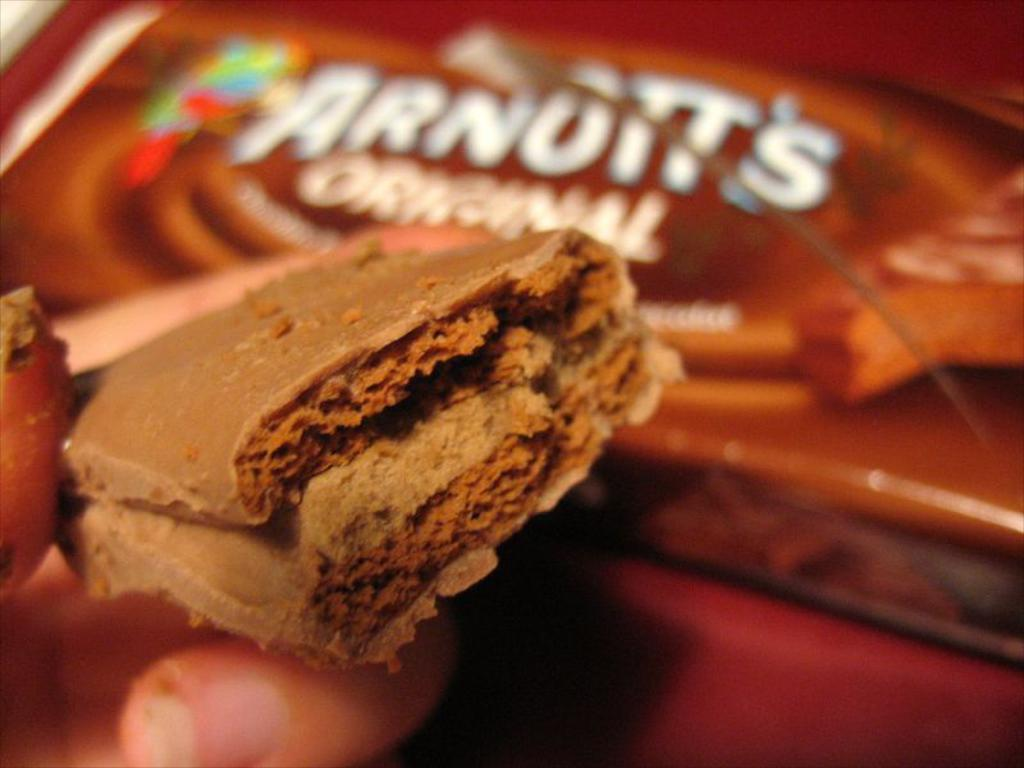What is the person on the left side of the image holding? The person is holding a chocolate in their hand. Where can the chocolate packet be found in the image? The chocolate packet is in the background of the image. What is the chocolate packet placed on? The chocolate packet is on a platform. What type of suit is the nation wearing in the image? There is no nation or suit present in the image. 